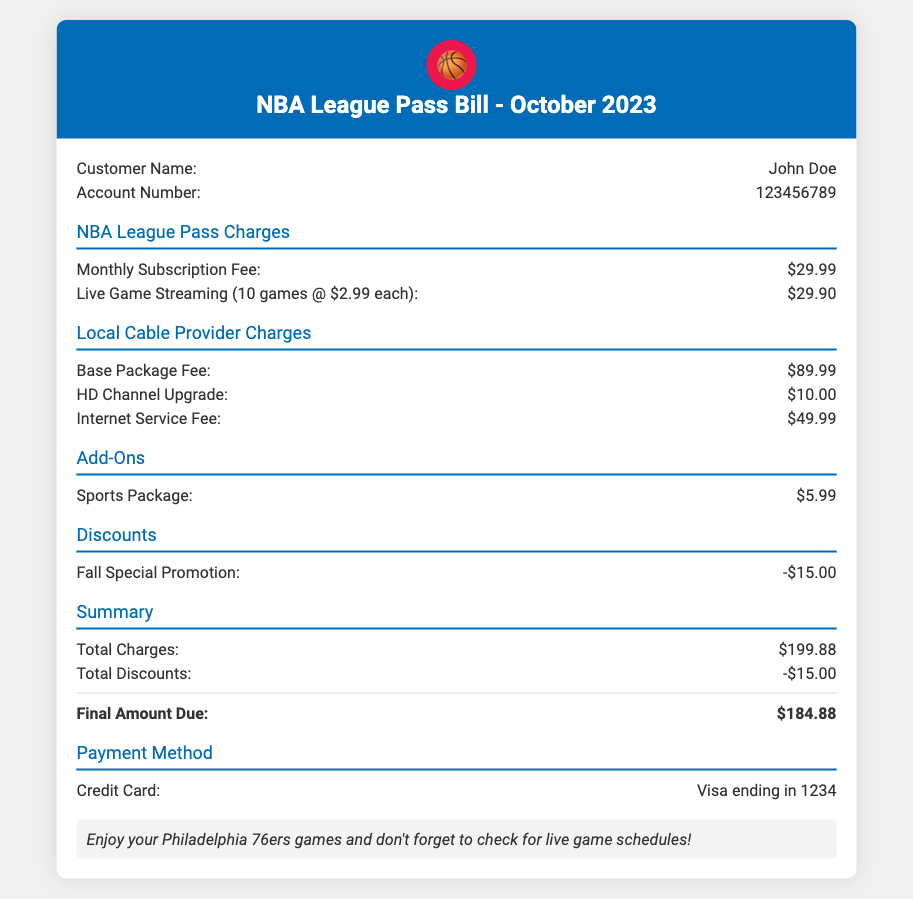What is the customer name? The customer name is provided in the document under "Customer Name", which is John Doe.
Answer: John Doe What is the total amount due? The total amount due is specified in the "Summary" section under "Final Amount Due", which is $184.88.
Answer: $184.88 How many games were streamed this month? The document shows that 10 games were streamed at a rate of $2.99 each, indicated in the "NBA League Pass Charges" section.
Answer: 10 games What is the charge for the NBA League Pass Monthly Subscription Fee? The subscription fee is listed in the "NBA League Pass Charges" section as $29.99.
Answer: $29.99 What discount was applied to the bill? The discount is noted under the "Discounts" section as a "Fall Special Promotion" for $15.00.
Answer: -$15.00 What is the base package fee for the local cable provider? The base package fee is detailed in the "Local Cable Provider Charges" section as $89.99.
Answer: $89.99 Which payment method is used? The payment method is listed in the "Payment Method" section as a Visa credit card ending in 1234.
Answer: Visa ending in 1234 What is the charge for live game streaming? The charge for live game streaming of 10 games is mentioned in the "NBA League Pass Charges" section as $29.90.
Answer: $29.90 What premium add-on is included in the bill? The document lists a "Sports Package" under the "Add-Ons" section, which costs $5.99.
Answer: $5.99 